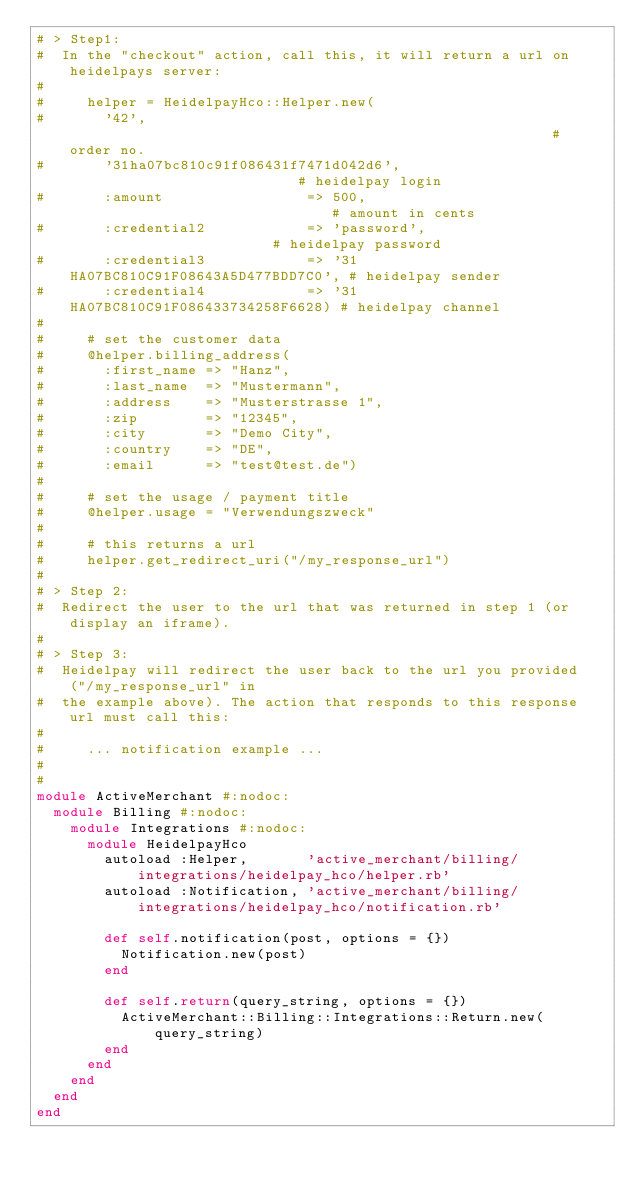Convert code to text. <code><loc_0><loc_0><loc_500><loc_500><_Ruby_># > Step1:
#  In the "checkout" action, call this, it will return a url on heidelpays server:
#
#     helper = HeidelpayHco::Helper.new(
#       '42',                                                          # order no.
#       '31ha07bc810c91f086431f7471d042d6',                            # heidelpay login
#       :amount                 => 500,                                # amount in cents
#       :credential2            => 'password',                         # heidelpay password
#       :credential3            => '31HA07BC810C91F08643A5D477BDD7C0', # heidelpay sender
#       :credential4            => '31HA07BC810C91F086433734258F6628) # heidelpay channel
#
#     # set the customer data
#     @helper.billing_address(
#       :first_name => "Hanz",
#       :last_name  => "Mustermann",
#       :address    => "Musterstrasse 1",
#       :zip        => "12345",
#       :city       => "Demo City",
#       :country    => "DE",
#       :email      => "test@test.de")
#
#     # set the usage / payment title
#     @helper.usage = "Verwendungszweck"
#
#     # this returns a url
#     helper.get_redirect_uri("/my_response_url")
#
# > Step 2:
#  Redirect the user to the url that was returned in step 1 (or display an iframe).
#
# > Step 3:
#  Heidelpay will redirect the user back to the url you provided ("/my_response_url" in
#  the example above). The action that responds to this response url must call this:
#
#     ... notification example ...
#
#
module ActiveMerchant #:nodoc:
  module Billing #:nodoc:
    module Integrations #:nodoc:
      module HeidelpayHco
        autoload :Helper,       'active_merchant/billing/integrations/heidelpay_hco/helper.rb'
        autoload :Notification, 'active_merchant/billing/integrations/heidelpay_hco/notification.rb'

        def self.notification(post, options = {})
          Notification.new(post)
        end

        def self.return(query_string, options = {})
          ActiveMerchant::Billing::Integrations::Return.new(query_string)
        end
      end
    end
  end
end
</code> 